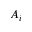<formula> <loc_0><loc_0><loc_500><loc_500>A _ { i }</formula> 